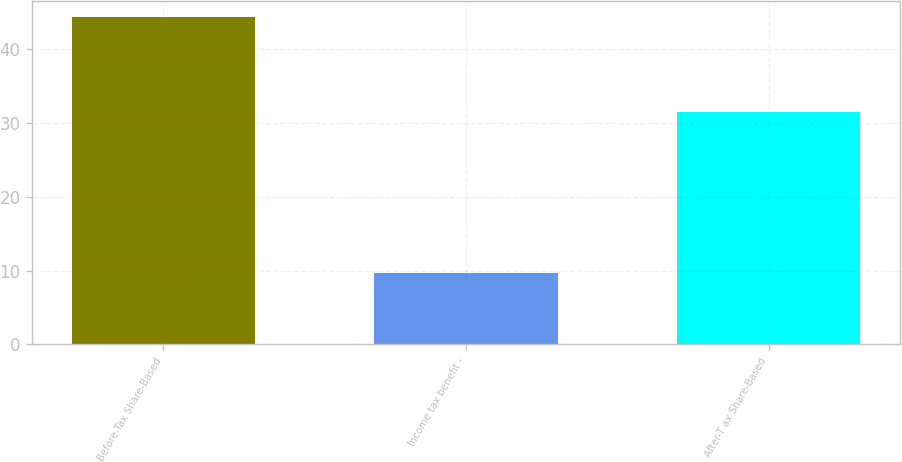Convert chart to OTSL. <chart><loc_0><loc_0><loc_500><loc_500><bar_chart><fcel>Before-Tax Share-Based<fcel>Income tax benefit -<fcel>After-T ax Share-Based<nl><fcel>44.35<fcel>9.7<fcel>31.5<nl></chart> 